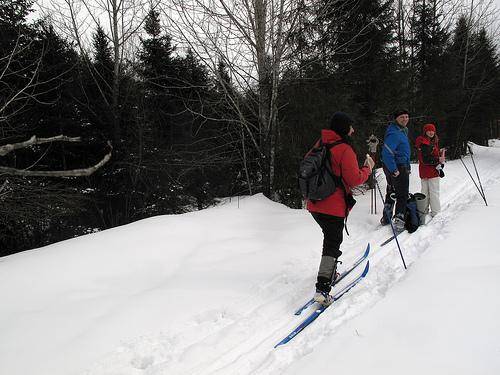Question: what is on the ground?
Choices:
A. Dirt.
B. Snow.
C. Mad.
D. Water.
Answer with the letter. Answer: B Question: why are the people bundled up?
Choices:
A. It is cold outside.
B. It's snowing.
C. It's raining.
D. They're playing.
Answer with the letter. Answer: A Question: what are the people doing?
Choices:
A. Swimming.
B. Skiing.
C. Dancing.
D. Laughing.
Answer with the letter. Answer: B Question: what type of skiing is shown?
Choices:
A. Downhill.
B. Cross country skiing.
C. Uphill.
D. Water.
Answer with the letter. Answer: B Question: where are the people?
Choices:
A. On the mountain.
B. On the slopes.
C. On a ski trail.
D. On the staircase.
Answer with the letter. Answer: C Question: what are the sticks called?
Choices:
A. Stripper poles.
B. Num chucks.
C. Rolling pins.
D. Ski poles.
Answer with the letter. Answer: D Question: when was the photo taken?
Choices:
A. In the summer.
B. In the fall.
C. In the spring.
D. In the winter.
Answer with the letter. Answer: D 